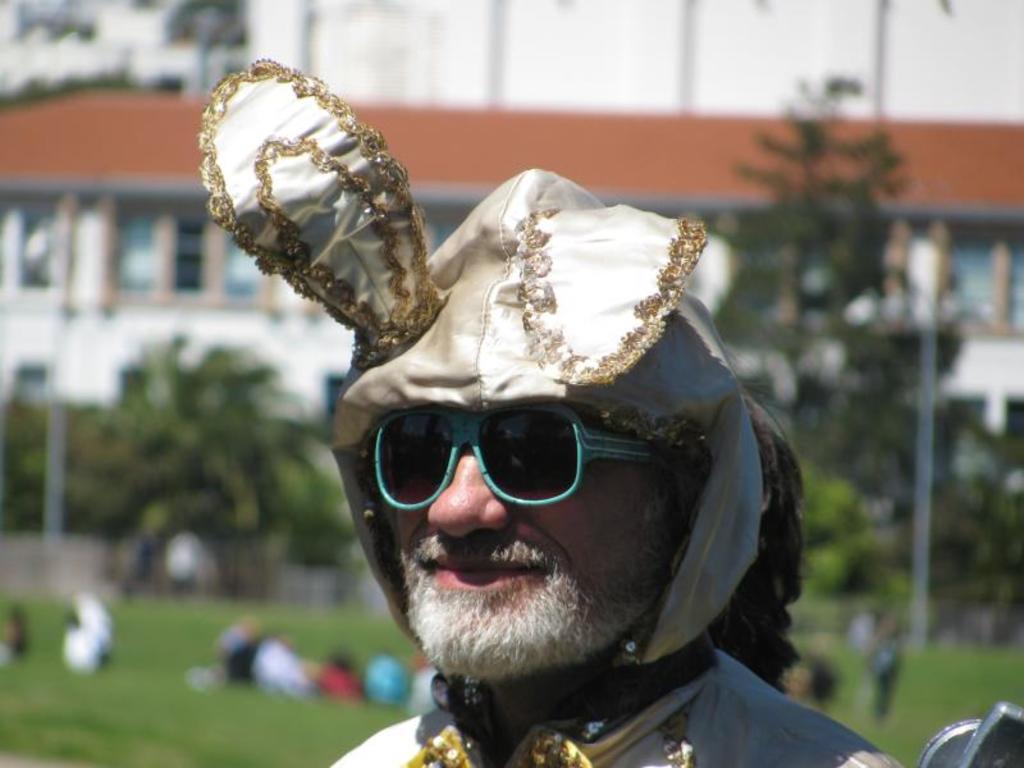Could you give a brief overview of what you see in this image? In the image we can see there is a man and he is wearing sunglasses and hat. Behind there is ground covered with grass and there are people lying on the ground. There are trees and buildings. Background of the image is little blurred. 